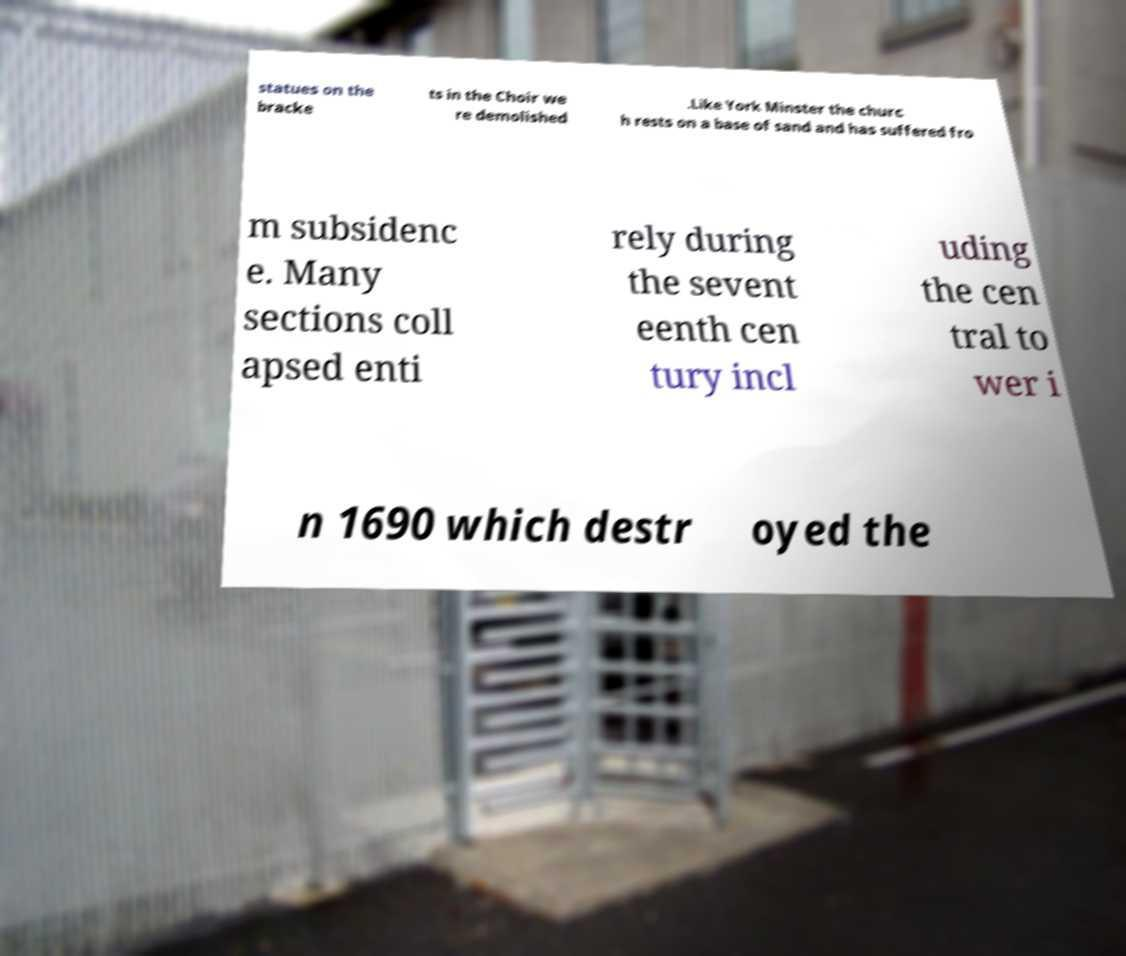For documentation purposes, I need the text within this image transcribed. Could you provide that? statues on the bracke ts in the Choir we re demolished .Like York Minster the churc h rests on a base of sand and has suffered fro m subsidenc e. Many sections coll apsed enti rely during the sevent eenth cen tury incl uding the cen tral to wer i n 1690 which destr oyed the 